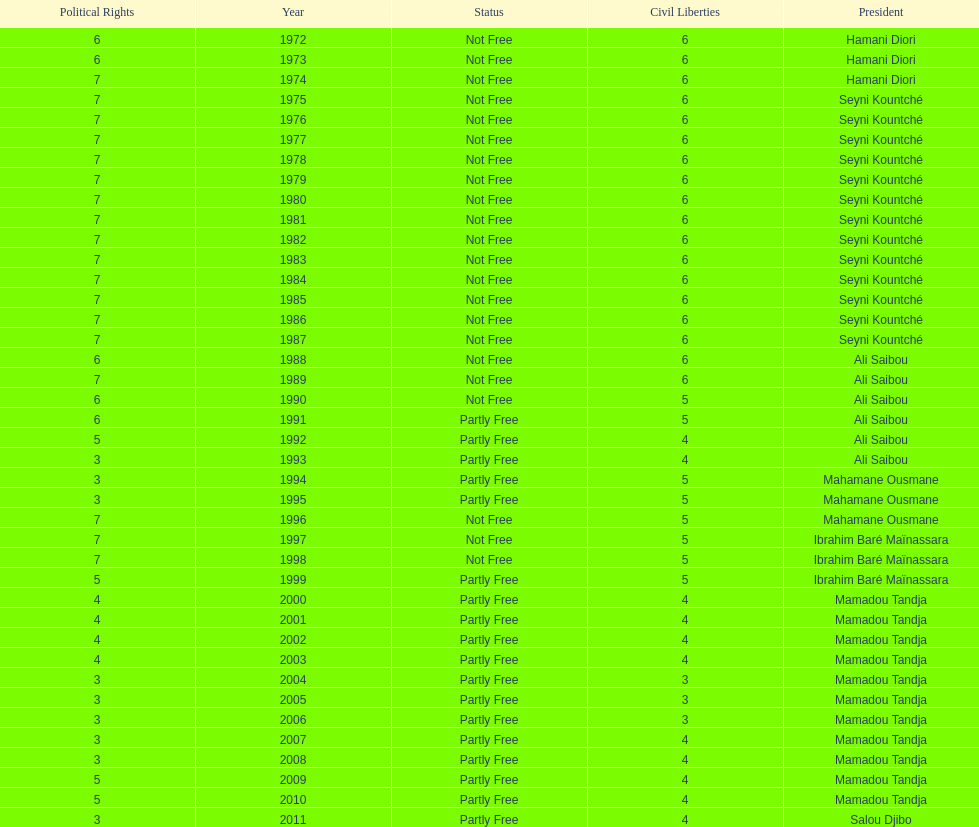How many years was it before the first partly free status? 18. 